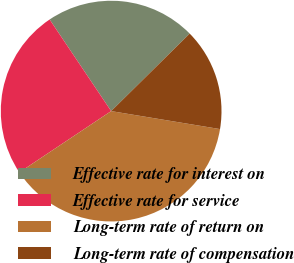Convert chart. <chart><loc_0><loc_0><loc_500><loc_500><pie_chart><fcel>Effective rate for interest on<fcel>Effective rate for service<fcel>Long-term rate of return on<fcel>Long-term rate of compensation<nl><fcel>22.02%<fcel>24.96%<fcel>38.03%<fcel>15.0%<nl></chart> 